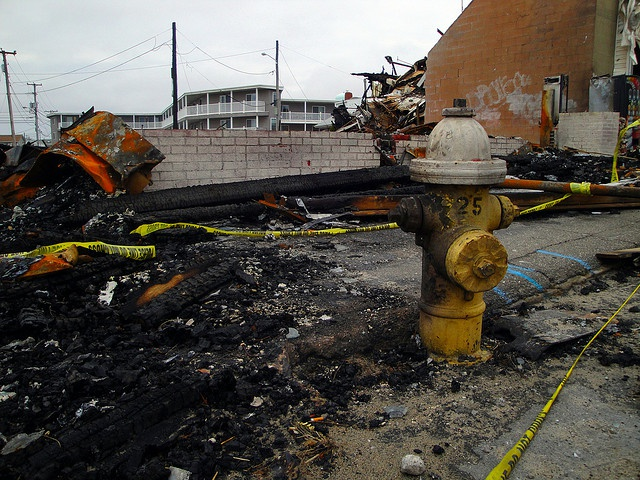Describe the objects in this image and their specific colors. I can see a fire hydrant in lightgray, black, olive, maroon, and darkgray tones in this image. 